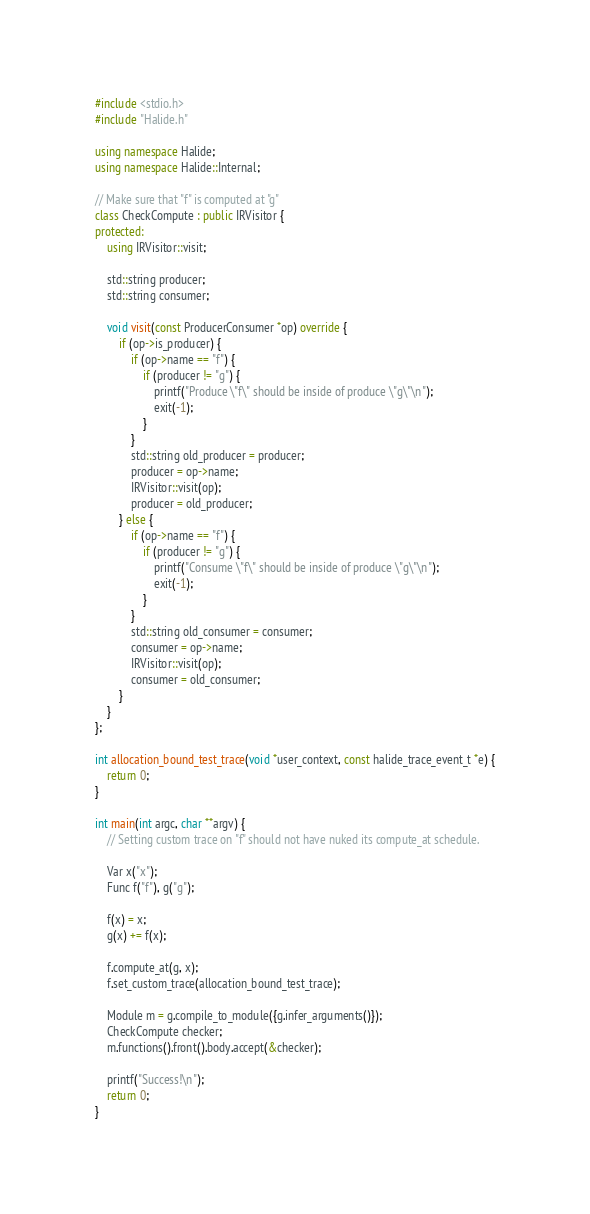Convert code to text. <code><loc_0><loc_0><loc_500><loc_500><_C++_>#include <stdio.h>
#include "Halide.h"

using namespace Halide;
using namespace Halide::Internal;

// Make sure that "f" is computed at "g"
class CheckCompute : public IRVisitor {
protected:
    using IRVisitor::visit;

    std::string producer;
    std::string consumer;

    void visit(const ProducerConsumer *op) override {
        if (op->is_producer) {
            if (op->name == "f") {
                if (producer != "g") {
                    printf("Produce \"f\" should be inside of produce \"g\"\n");
                    exit(-1);
                }
            }
            std::string old_producer = producer;
            producer = op->name;
            IRVisitor::visit(op);
            producer = old_producer;
        } else {
            if (op->name == "f") {
                if (producer != "g") {
                    printf("Consume \"f\" should be inside of produce \"g\"\n");
                    exit(-1);
                }
            }
            std::string old_consumer = consumer;
            consumer = op->name;
            IRVisitor::visit(op);
            consumer = old_consumer;
        }
    }
};

int allocation_bound_test_trace(void *user_context, const halide_trace_event_t *e) {
    return 0;
}

int main(int argc, char **argv) {
    // Setting custom trace on "f" should not have nuked its compute_at schedule.

    Var x("x");
    Func f("f"), g("g");

    f(x) = x;
    g(x) += f(x);

    f.compute_at(g, x);
    f.set_custom_trace(allocation_bound_test_trace);

    Module m = g.compile_to_module({g.infer_arguments()});
    CheckCompute checker;
    m.functions().front().body.accept(&checker);

    printf("Success!\n");
    return 0;
}
</code> 